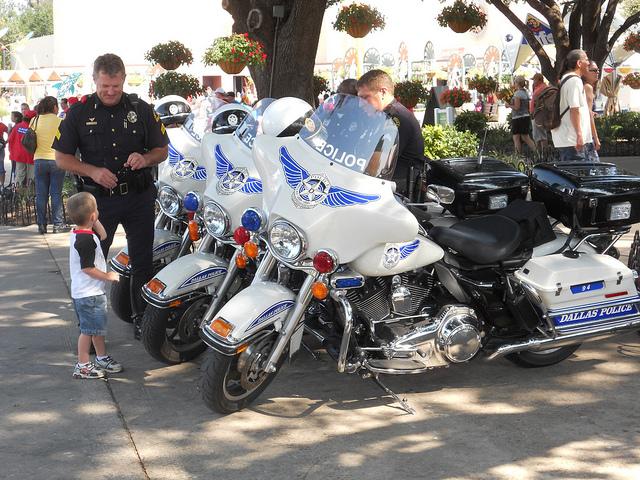Where are these police officers stationed?
Keep it brief. Dallas. Are there a lot of motorcycles?
Be succinct. Yes. Why are the people in uniform?
Quick response, please. Police. Are these all police officers?
Quick response, please. No. Is the man a policeman?
Keep it brief. Yes. What is the little boy doing?
Quick response, please. Talking to police. 